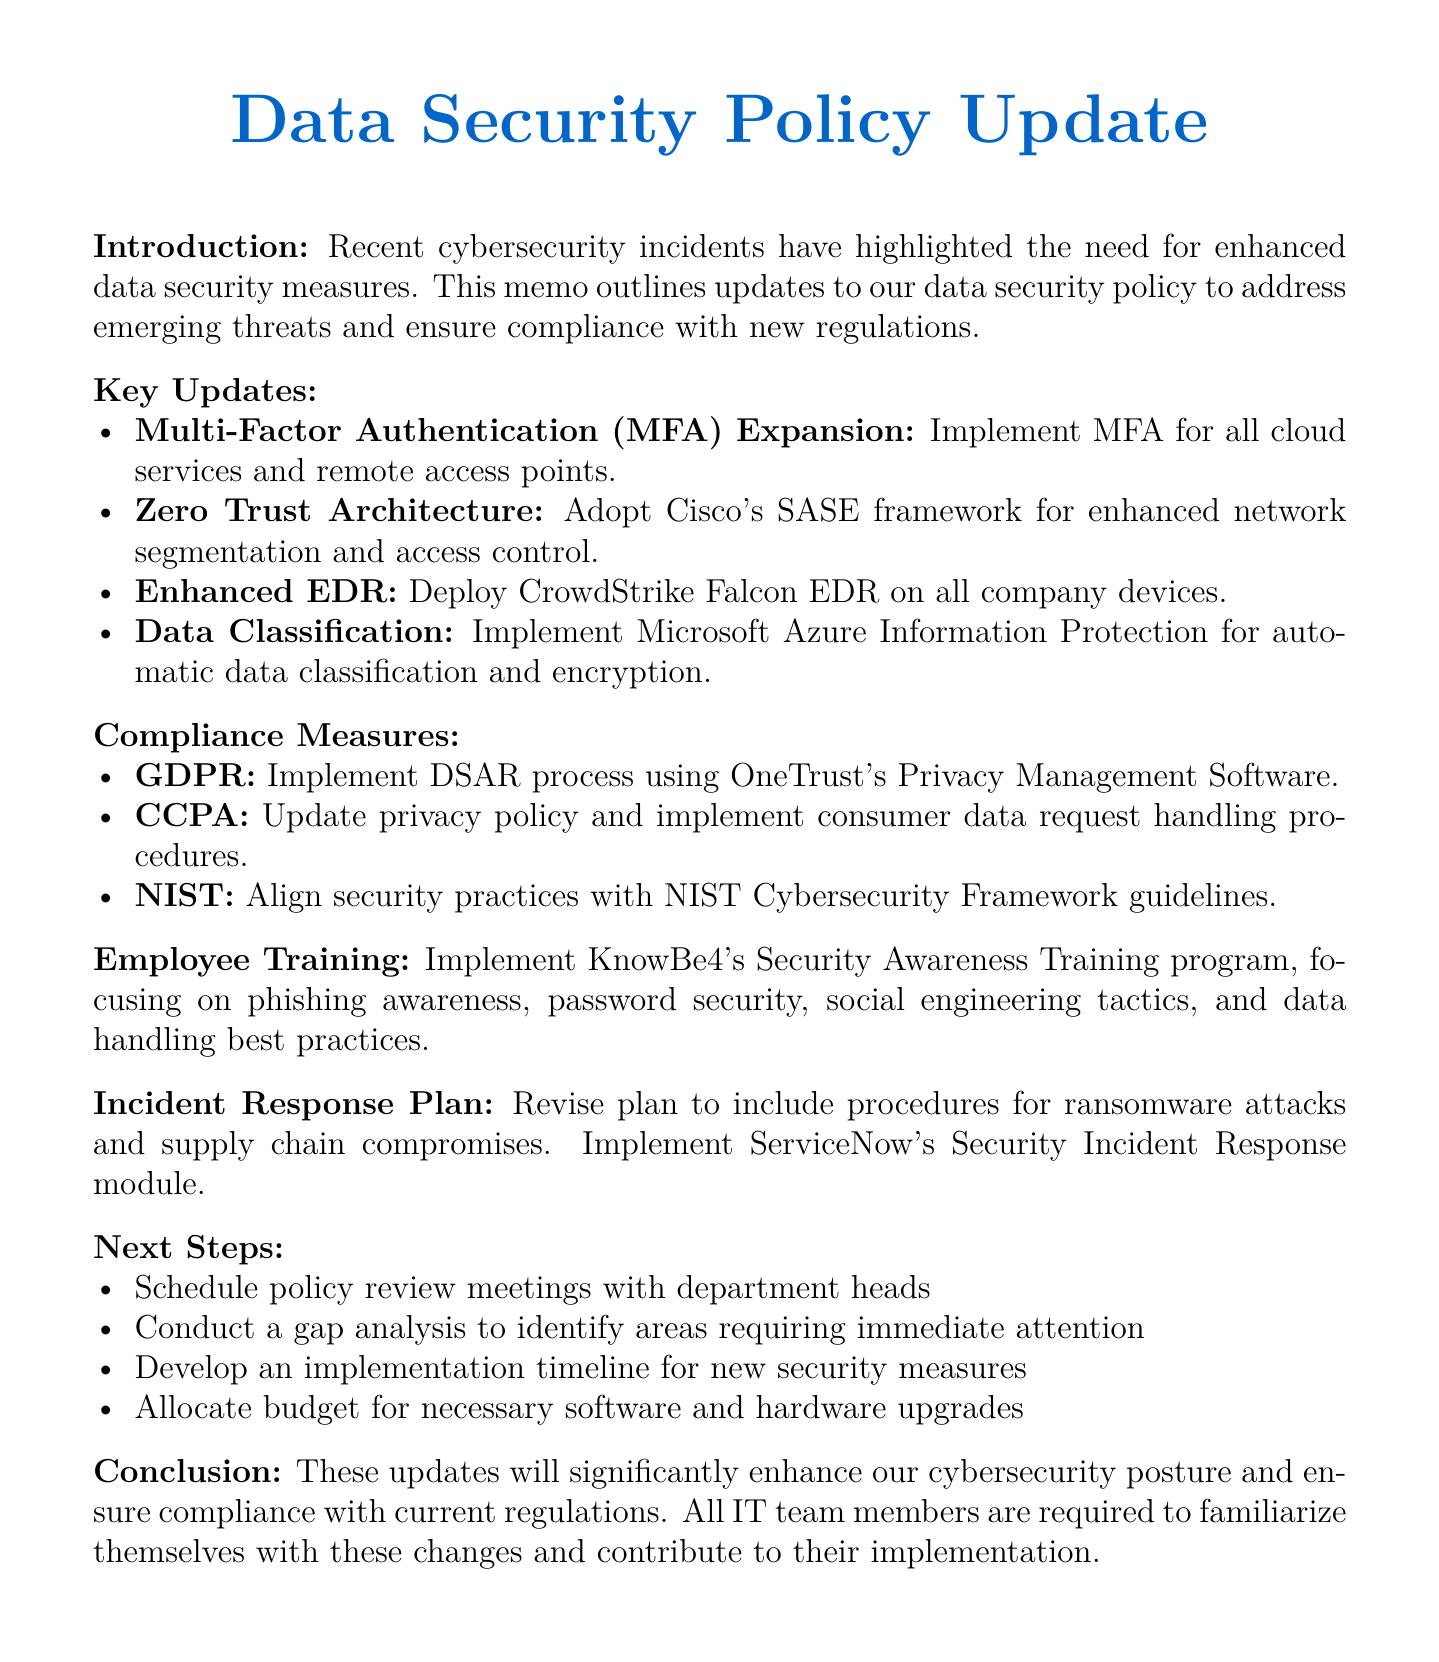What is the title of the memo? The title of the memo is provided at the beginning, indicating the subject of the document.
Answer: Data Security Policy Update: Addressing Recent Cybersecurity Threats and Compliance Requirements What security measure is being expanded? The document specifically mentions the expansion of a security measure in the key updates section.
Answer: Multi-Factor Authentication (MFA) Expansion Which framework is used for Zero Trust Architecture? The framework for Zero Trust Architecture is explicitly stated in the document's key updates section.
Answer: Cisco's Secure Access Service Edge (SASE) What training program is being implemented for employees? The memo discusses a specific training program for employee awareness in the employee training section.
Answer: KnowBe4's Security Awareness Training program What is the action taken for GDPR compliance? The document lists a specific action for compliance with GDPR in the compliance measures section.
Answer: Implement data subject access request (DSAR) process using OneTrust's Privacy Management Software How many core functions are aligned with the NIST Cybersecurity Framework? The number of core functions is derived from the summary of actions related to NIST guidelines.
Answer: Five What incident response tool is mentioned in the document? The document outlines a specific tool for managing incidents in the incident response plan section.
Answer: ServiceNow's Security Incident Response module What are the focus areas for employee training? The focus areas are listed in the employee training section, summarizing the essential training topics.
Answer: Phishing awareness, Password security, Social engineering tactics, Data handling best practices What is the next step involving department heads? The next step related to department heads is listed under the next steps section of the memo.
Answer: Schedule policy review meetings with department heads 